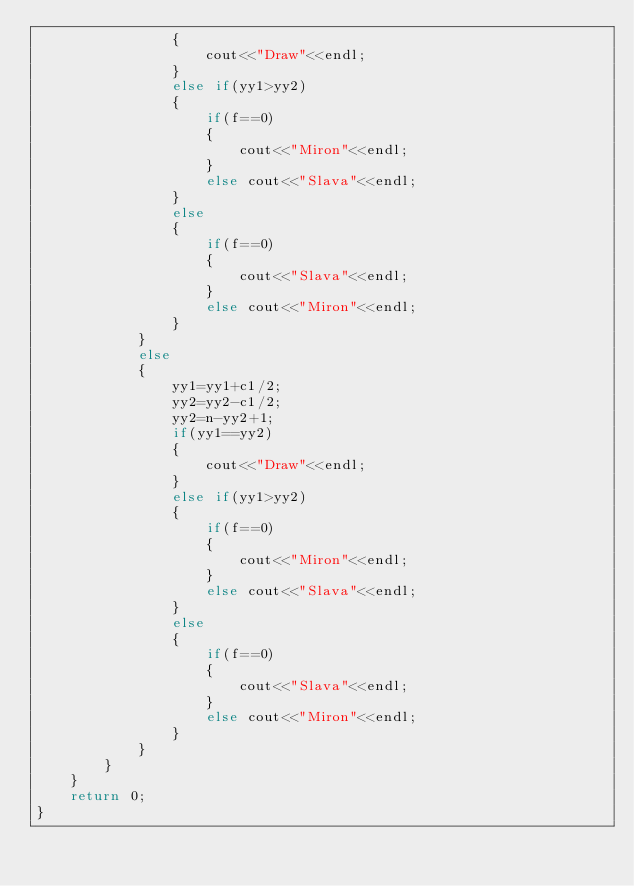Convert code to text. <code><loc_0><loc_0><loc_500><loc_500><_C++_>                {
                    cout<<"Draw"<<endl;
                }
                else if(yy1>yy2)
                {
                    if(f==0)
                    {
                        cout<<"Miron"<<endl;
                    }
                    else cout<<"Slava"<<endl;
                }
                else
                {
                    if(f==0)
                    {
                        cout<<"Slava"<<endl;
                    }
                    else cout<<"Miron"<<endl;
                }
            }
            else
            {
                yy1=yy1+c1/2;
                yy2=yy2-c1/2;
                yy2=n-yy2+1;
                if(yy1==yy2)
                {
                    cout<<"Draw"<<endl;
                }
                else if(yy1>yy2)
                {
                    if(f==0)
                    {
                        cout<<"Miron"<<endl;
                    }
                    else cout<<"Slava"<<endl;
                }
                else
                {
                    if(f==0)
                    {
                        cout<<"Slava"<<endl;
                    }
                    else cout<<"Miron"<<endl;
                }
            }
        }
    }
    return 0;
}</code> 